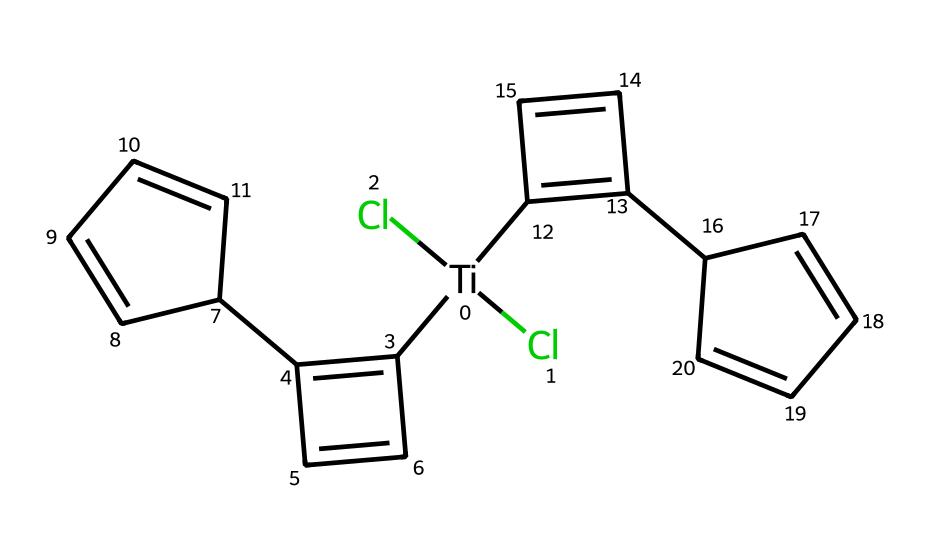What is the central metal atom in titanocene dichloride? The chemical structure indicates that the central atom is titanium, as it is represented by the notation [Ti] in the SMILES.
Answer: titanium How many chlorine atoms are present in titanocene dichloride? From the SMILES representation, there are two chlorine atoms indicated by (Cl)(Cl).
Answer: 2 What type of bonding is predominantly found in titanocene dichloride? The presence of titanium and the chlorine suggests coordination bonding typical for organometallics, in addition to covalent bonds within the organic rings.
Answer: coordination What is the total number of aromatic rings in titanocene dichloride? Analyzing the organic parts of the SMILES, there are two sets of C=C double bonds indicating two distinct aromatic rings.
Answer: 2 How does the structure of titanocene dichloride illustrate organometallic characteristics? The structure shows a metal center (titanium) bonded to organic residues (aromatic rings), reflecting the definition of organometallic compounds.
Answer: metal center What potential application is mentioned for titanocene dichloride based on its structure? Titanocene dichloride is noted for its potential applications in cancer treatment, likely due to its distinct structure influencing biological interactions.
Answer: cancer treatment 